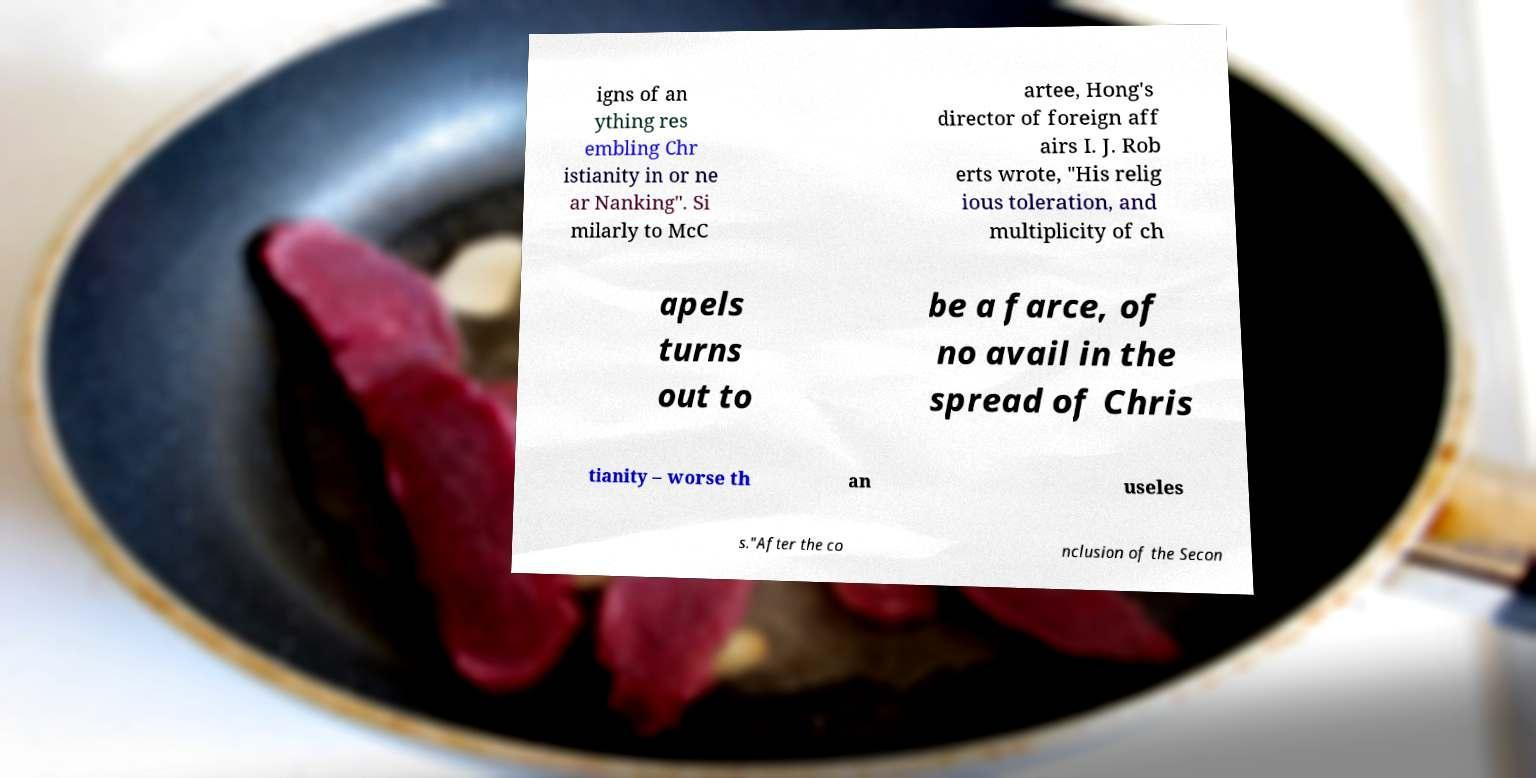Can you accurately transcribe the text from the provided image for me? igns of an ything res embling Chr istianity in or ne ar Nanking". Si milarly to McC artee, Hong's director of foreign aff airs I. J. Rob erts wrote, "His relig ious toleration, and multiplicity of ch apels turns out to be a farce, of no avail in the spread of Chris tianity – worse th an useles s."After the co nclusion of the Secon 